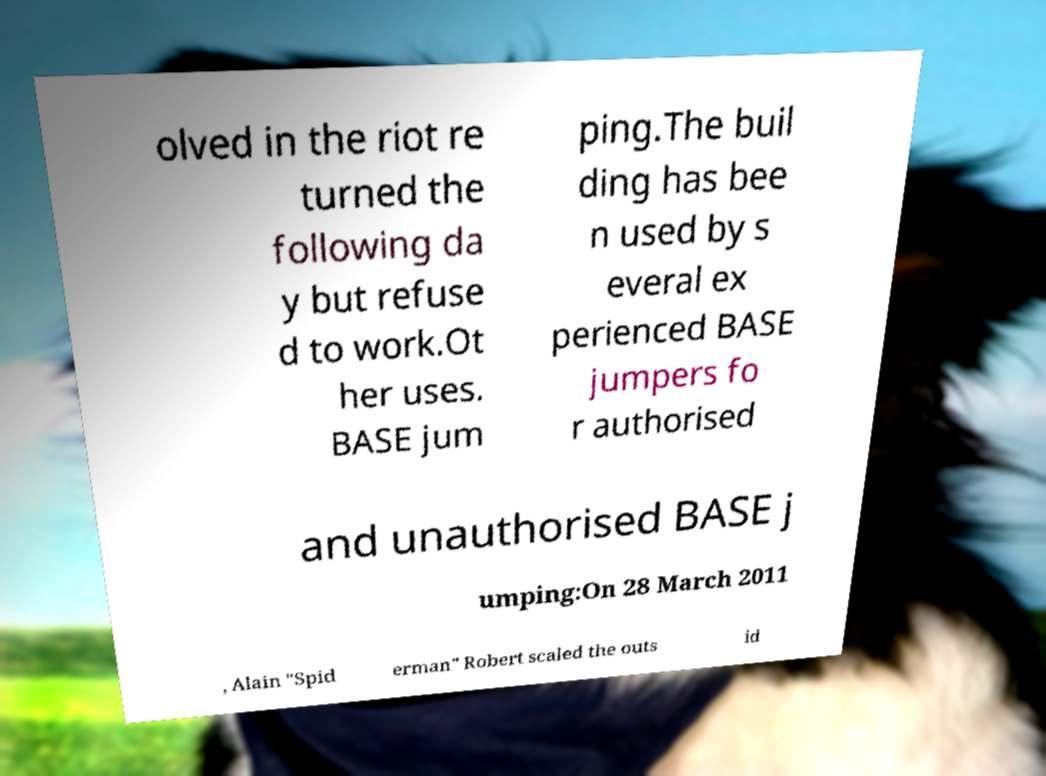Can you accurately transcribe the text from the provided image for me? olved in the riot re turned the following da y but refuse d to work.Ot her uses. BASE jum ping.The buil ding has bee n used by s everal ex perienced BASE jumpers fo r authorised and unauthorised BASE j umping:On 28 March 2011 , Alain "Spid erman" Robert scaled the outs id 